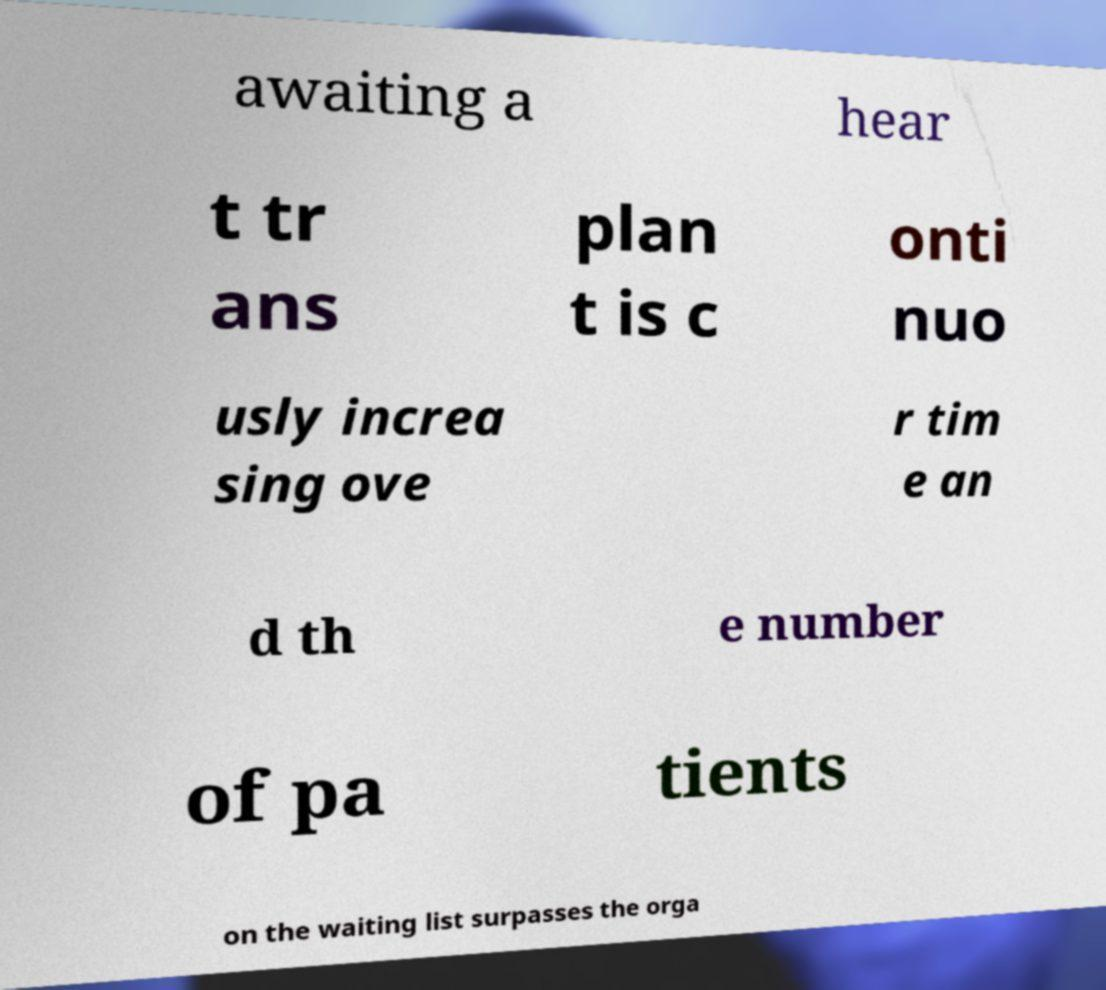Could you assist in decoding the text presented in this image and type it out clearly? awaiting a hear t tr ans plan t is c onti nuo usly increa sing ove r tim e an d th e number of pa tients on the waiting list surpasses the orga 